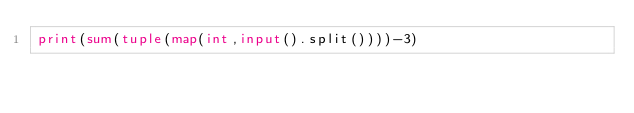Convert code to text. <code><loc_0><loc_0><loc_500><loc_500><_Python_>print(sum(tuple(map(int,input().split())))-3)
</code> 